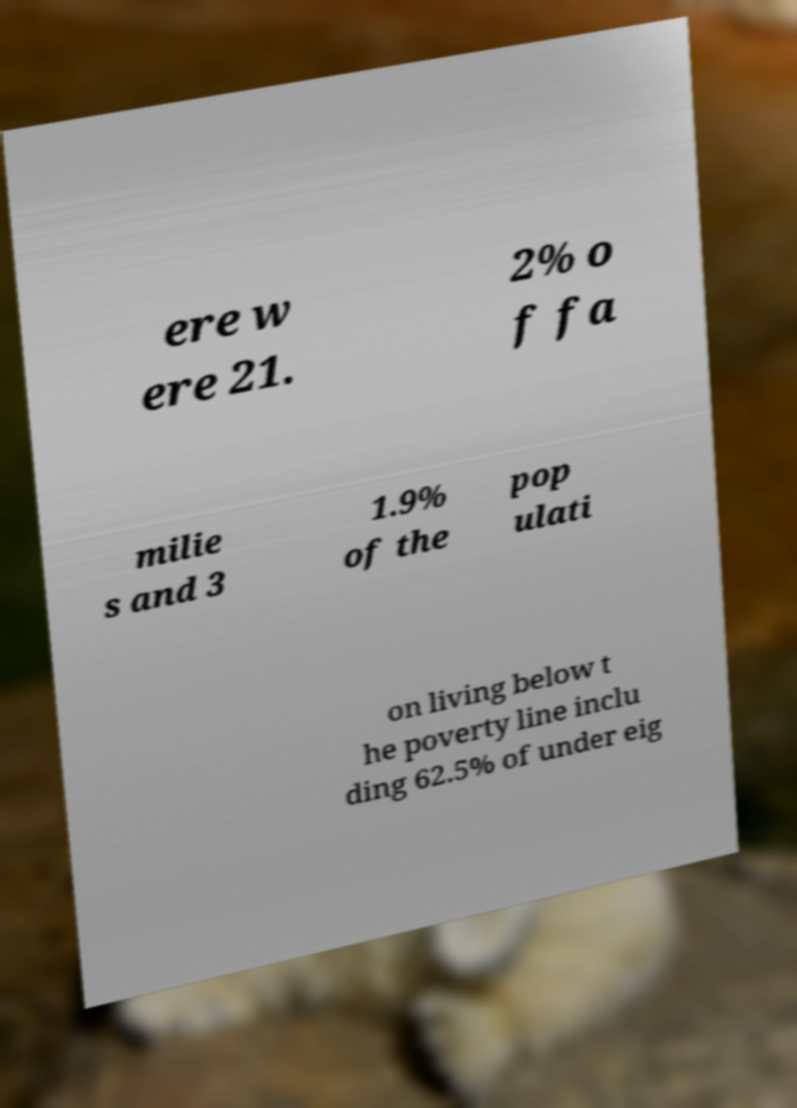Could you extract and type out the text from this image? ere w ere 21. 2% o f fa milie s and 3 1.9% of the pop ulati on living below t he poverty line inclu ding 62.5% of under eig 